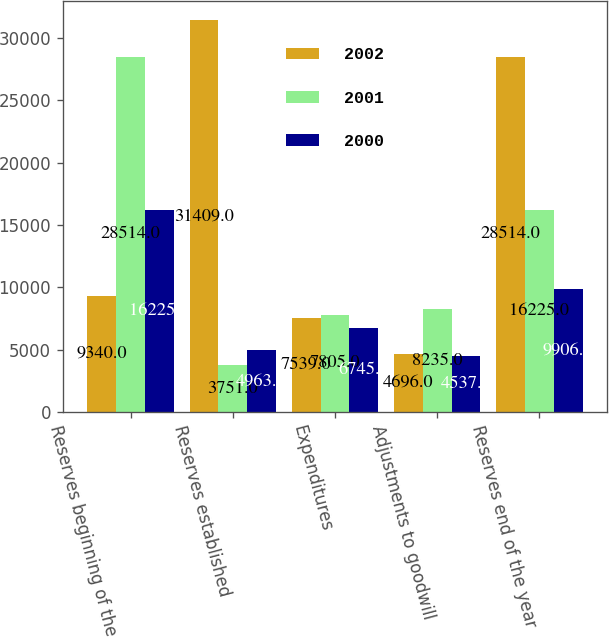Convert chart. <chart><loc_0><loc_0><loc_500><loc_500><stacked_bar_chart><ecel><fcel>Reserves beginning of the year<fcel>Reserves established<fcel>Expenditures<fcel>Adjustments to goodwill<fcel>Reserves end of the year<nl><fcel>2002<fcel>9340<fcel>31409<fcel>7539<fcel>4696<fcel>28514<nl><fcel>2001<fcel>28514<fcel>3751<fcel>7805<fcel>8235<fcel>16225<nl><fcel>2000<fcel>16225<fcel>4963<fcel>6745<fcel>4537<fcel>9906<nl></chart> 